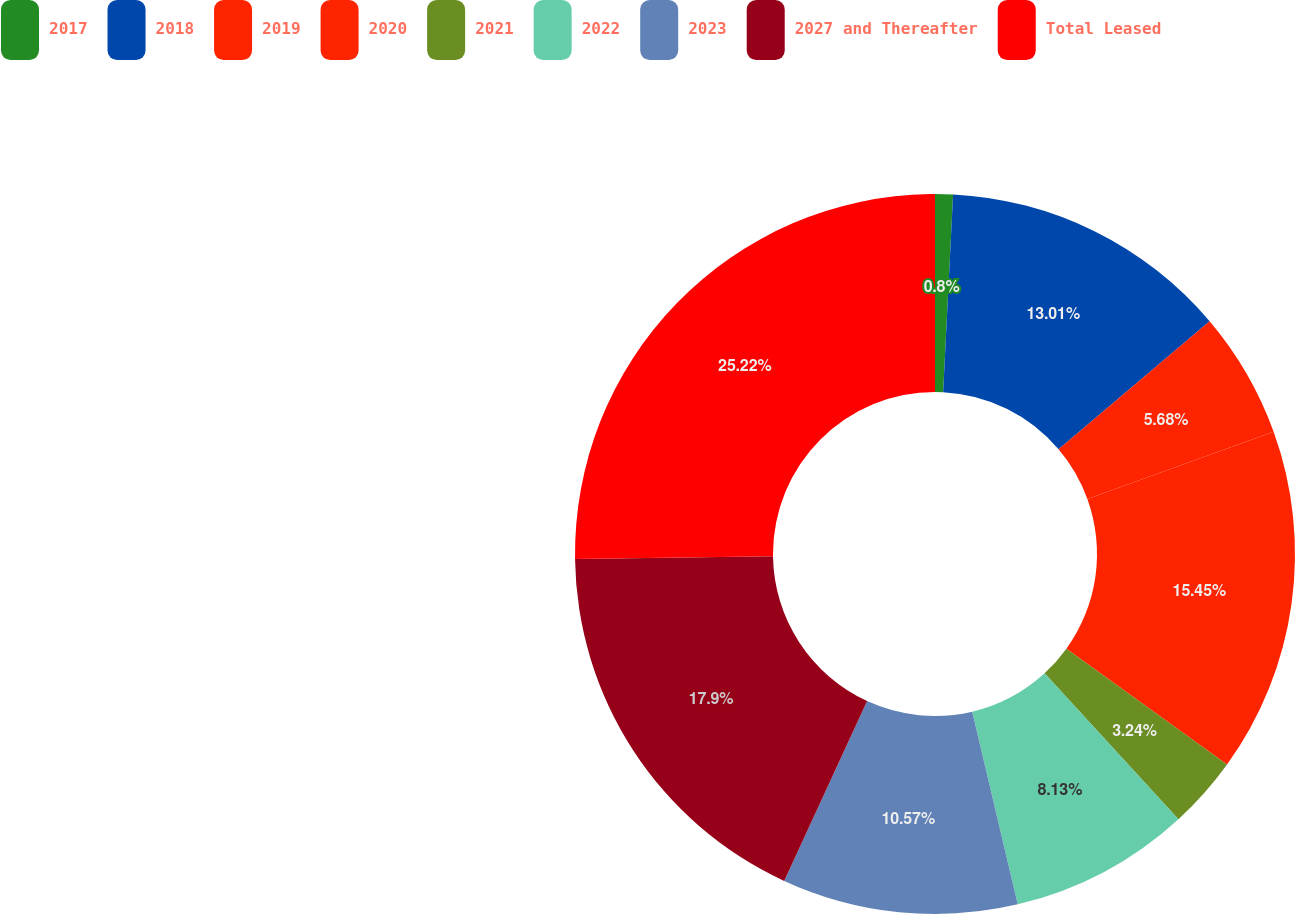Convert chart. <chart><loc_0><loc_0><loc_500><loc_500><pie_chart><fcel>2017<fcel>2018<fcel>2019<fcel>2020<fcel>2021<fcel>2022<fcel>2023<fcel>2027 and Thereafter<fcel>Total Leased<nl><fcel>0.8%<fcel>13.01%<fcel>5.68%<fcel>15.45%<fcel>3.24%<fcel>8.13%<fcel>10.57%<fcel>17.9%<fcel>25.22%<nl></chart> 